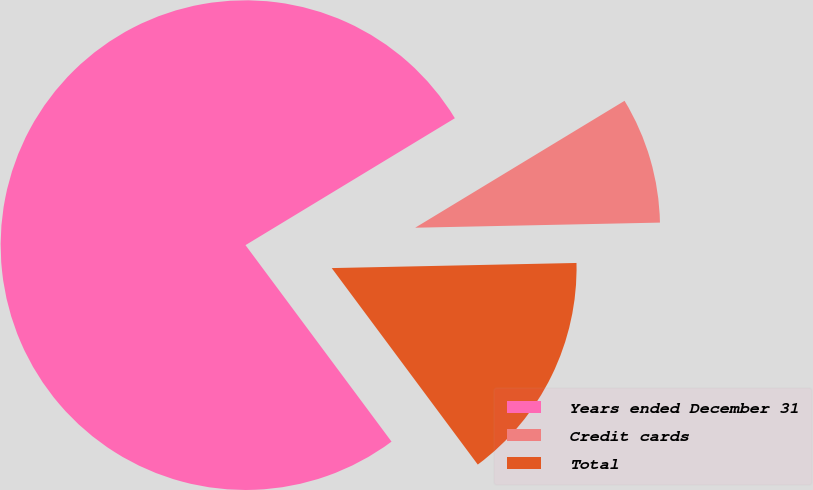Convert chart. <chart><loc_0><loc_0><loc_500><loc_500><pie_chart><fcel>Years ended December 31<fcel>Credit cards<fcel>Total<nl><fcel>76.5%<fcel>8.34%<fcel>15.16%<nl></chart> 